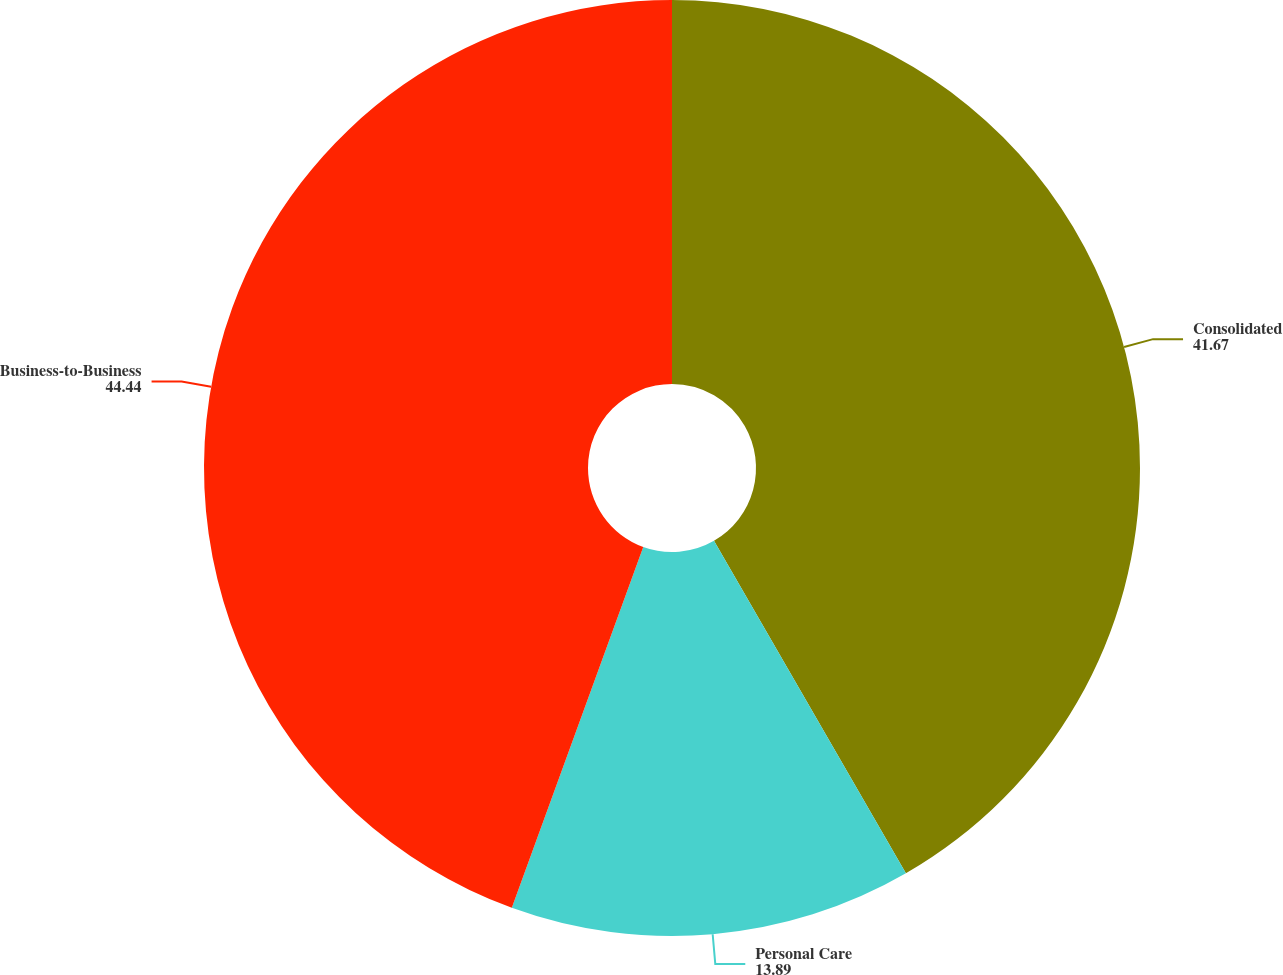Convert chart. <chart><loc_0><loc_0><loc_500><loc_500><pie_chart><fcel>Consolidated<fcel>Personal Care<fcel>Business-to-Business<nl><fcel>41.67%<fcel>13.89%<fcel>44.44%<nl></chart> 